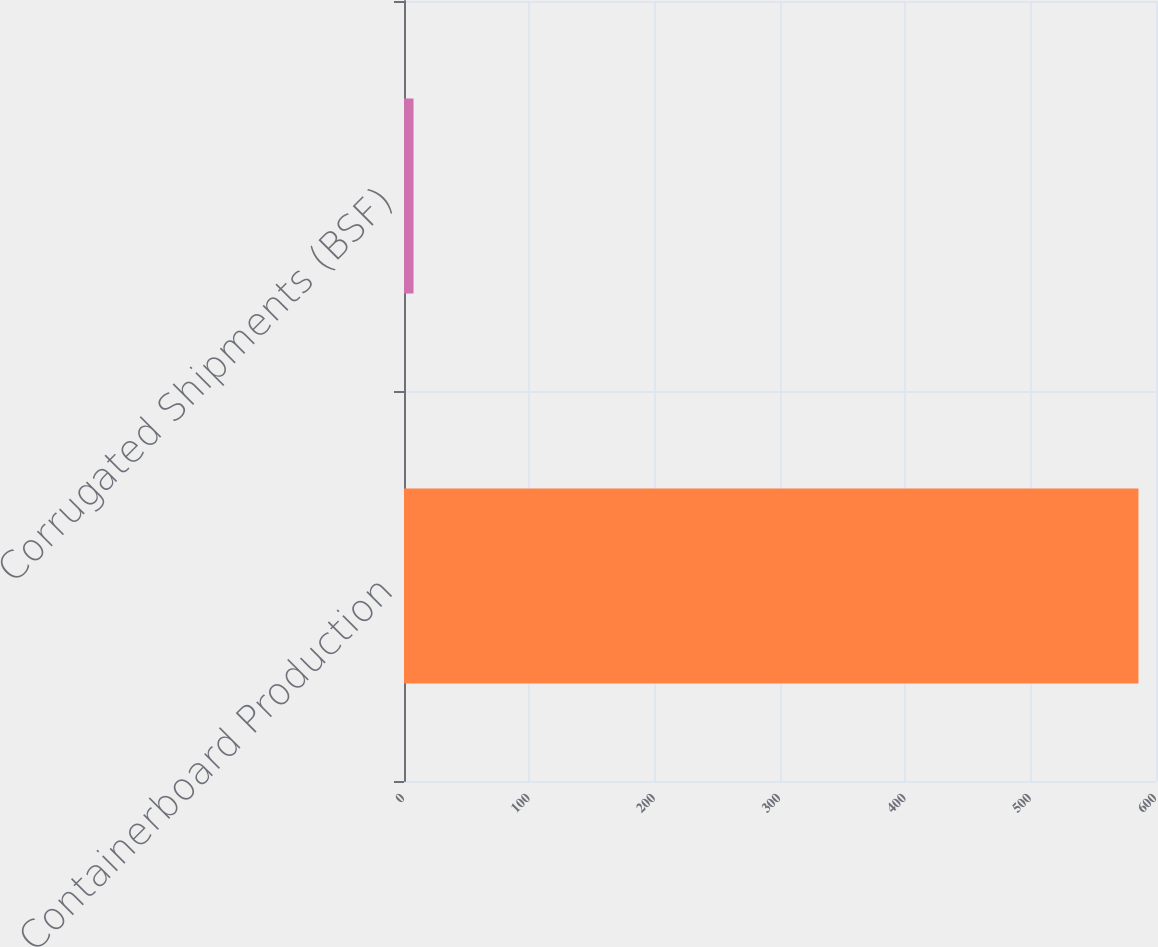Convert chart. <chart><loc_0><loc_0><loc_500><loc_500><bar_chart><fcel>Containerboard Production<fcel>Corrugated Shipments (BSF)<nl><fcel>586<fcel>7.6<nl></chart> 